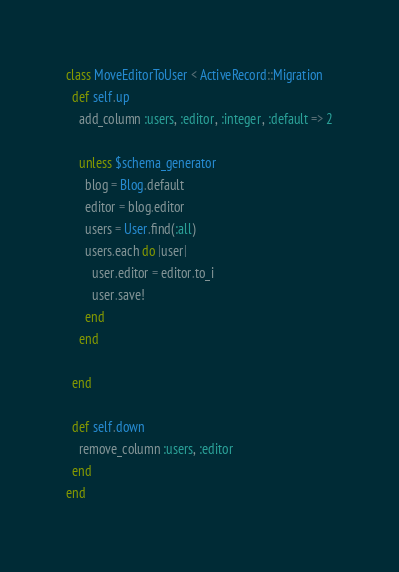<code> <loc_0><loc_0><loc_500><loc_500><_Ruby_>class MoveEditorToUser < ActiveRecord::Migration
  def self.up
    add_column :users, :editor, :integer, :default => 2
    
    unless $schema_generator
      blog = Blog.default
      editor = blog.editor
      users = User.find(:all)
      users.each do |user|
        user.editor = editor.to_i
        user.save!
      end
    end
    
  end

  def self.down
    remove_column :users, :editor
  end
end
</code> 